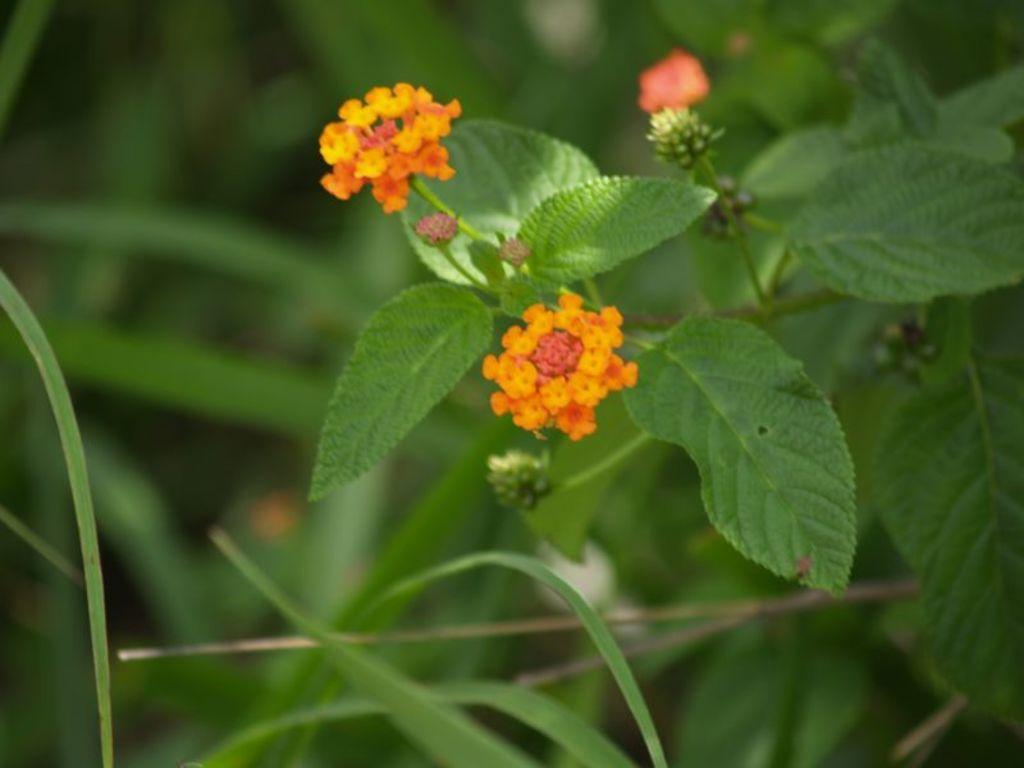How would you summarize this image in a sentence or two? This image consists of flowers in orange color along with green leaves. In the background, there are plants. 